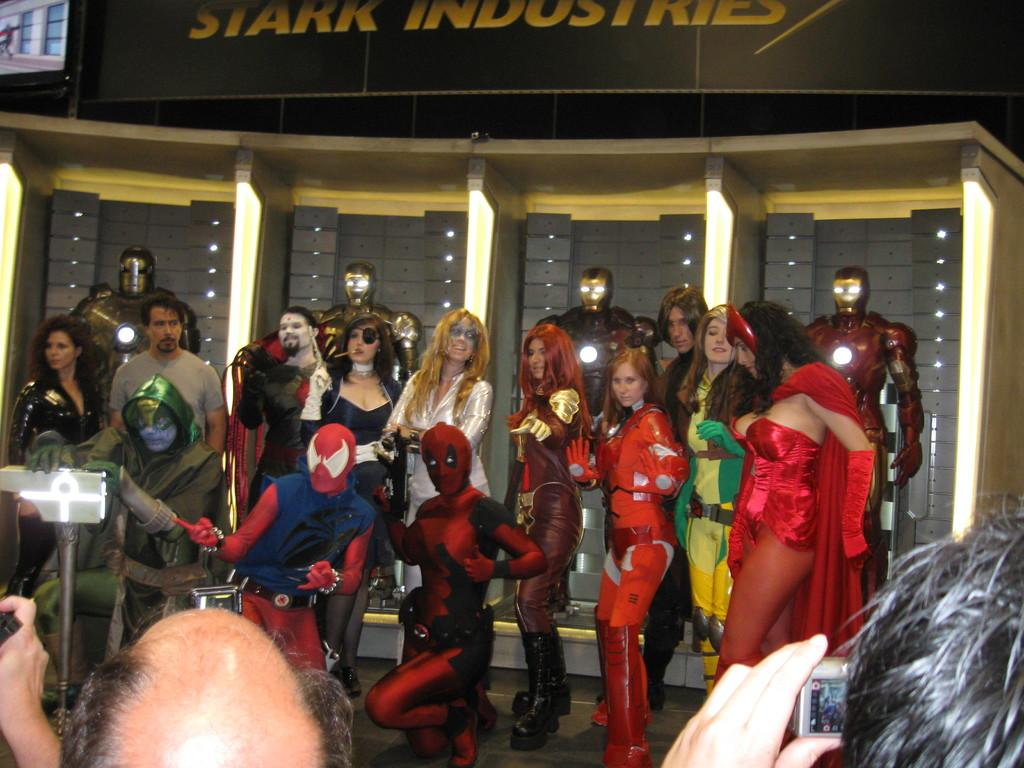What are the persons in the image wearing? The persons in the image are wearing different types of costumes. What can be seen in the background of the image? There are metal objects and a board with some text written on it in the background of the image. What type of pipe can be seen in the image? There is no pipe present in the image. What industry is depicted in the image? The image does not depict any specific industry; it features persons wearing costumes and objects in the background. 